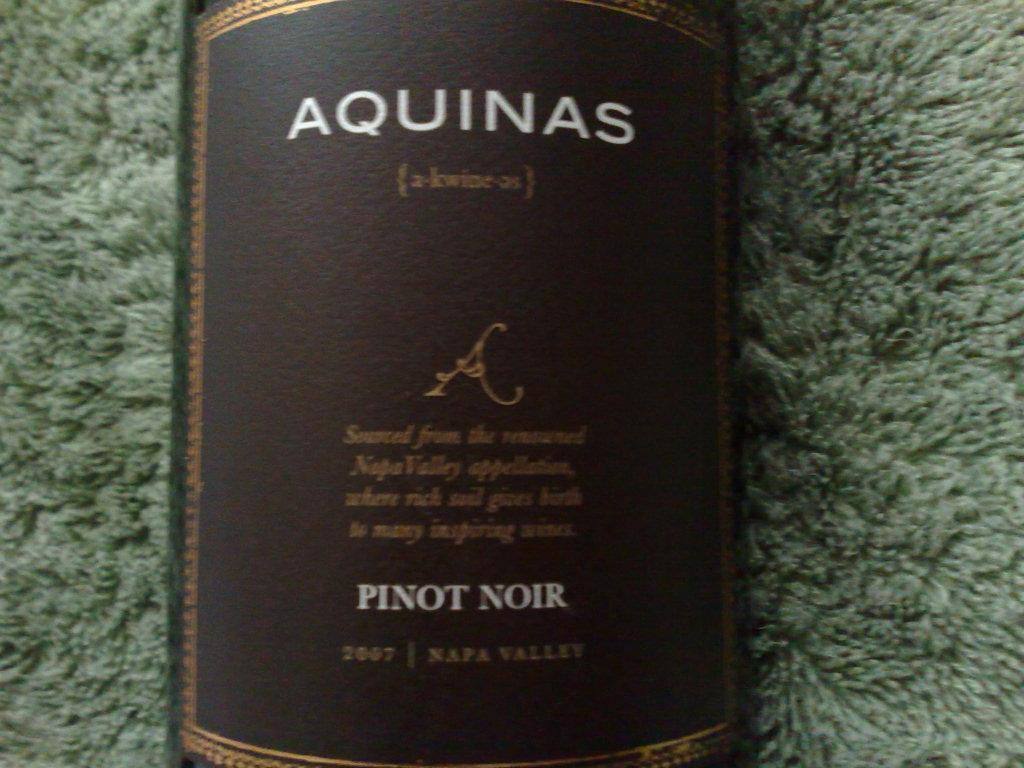Provide a one-sentence caption for the provided image. An old brown Aquinas bottle of Pinot Noir. 